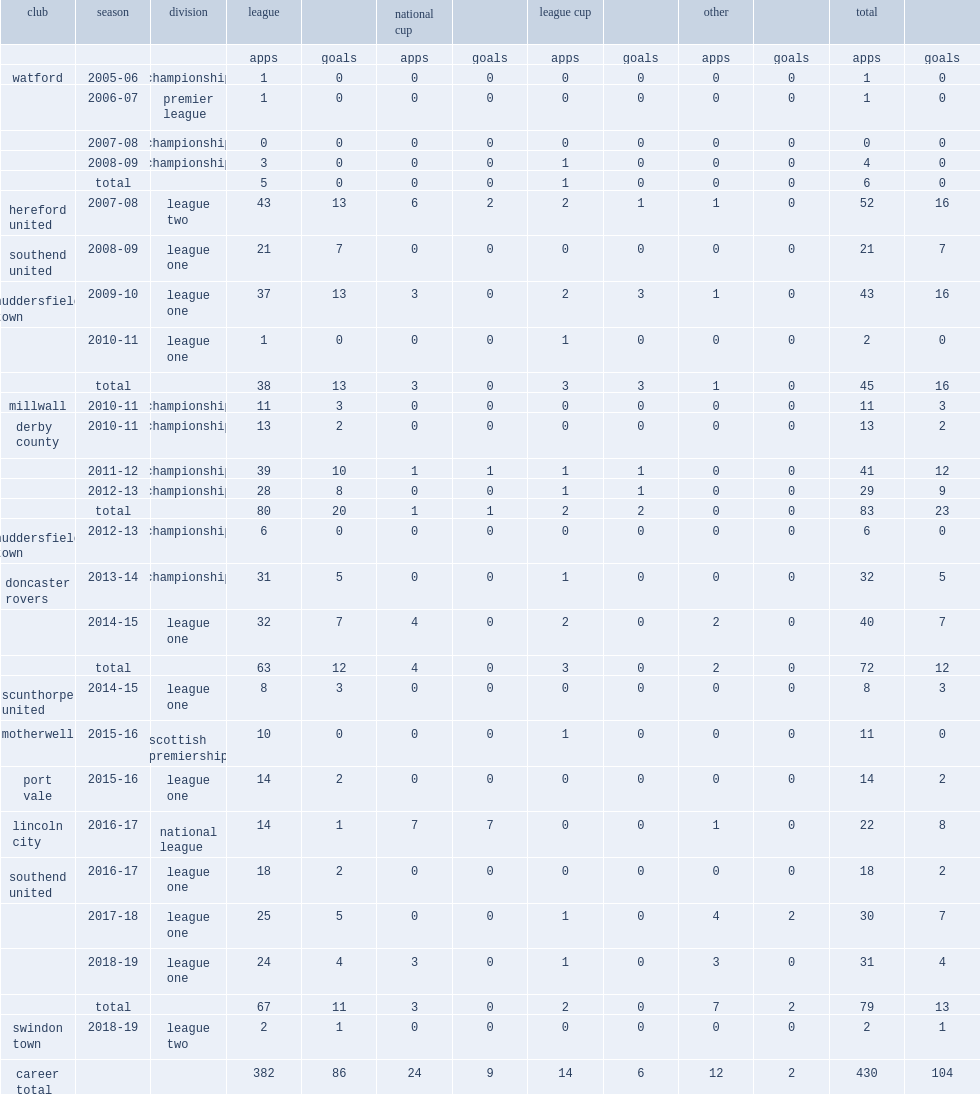Which league did robinson appear= for watford? Premier league. 